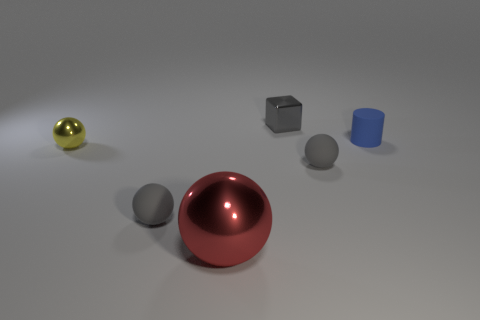Subtract all gray balls. How many were subtracted if there are1gray balls left? 1 Subtract all tiny yellow spheres. How many spheres are left? 3 Subtract all gray cylinders. How many gray balls are left? 2 Subtract all red spheres. How many spheres are left? 3 Add 4 tiny cylinders. How many objects exist? 10 Subtract all cylinders. How many objects are left? 5 Subtract all purple spheres. Subtract all yellow cylinders. How many spheres are left? 4 Subtract 1 red spheres. How many objects are left? 5 Subtract all green matte blocks. Subtract all yellow spheres. How many objects are left? 5 Add 6 gray things. How many gray things are left? 9 